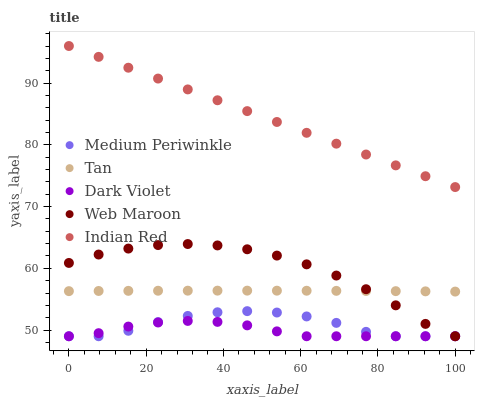Does Dark Violet have the minimum area under the curve?
Answer yes or no. Yes. Does Indian Red have the maximum area under the curve?
Answer yes or no. Yes. Does Tan have the minimum area under the curve?
Answer yes or no. No. Does Tan have the maximum area under the curve?
Answer yes or no. No. Is Indian Red the smoothest?
Answer yes or no. Yes. Is Medium Periwinkle the roughest?
Answer yes or no. Yes. Is Tan the smoothest?
Answer yes or no. No. Is Tan the roughest?
Answer yes or no. No. Does Web Maroon have the lowest value?
Answer yes or no. Yes. Does Tan have the lowest value?
Answer yes or no. No. Does Indian Red have the highest value?
Answer yes or no. Yes. Does Tan have the highest value?
Answer yes or no. No. Is Medium Periwinkle less than Tan?
Answer yes or no. Yes. Is Tan greater than Medium Periwinkle?
Answer yes or no. Yes. Does Medium Periwinkle intersect Web Maroon?
Answer yes or no. Yes. Is Medium Periwinkle less than Web Maroon?
Answer yes or no. No. Is Medium Periwinkle greater than Web Maroon?
Answer yes or no. No. Does Medium Periwinkle intersect Tan?
Answer yes or no. No. 